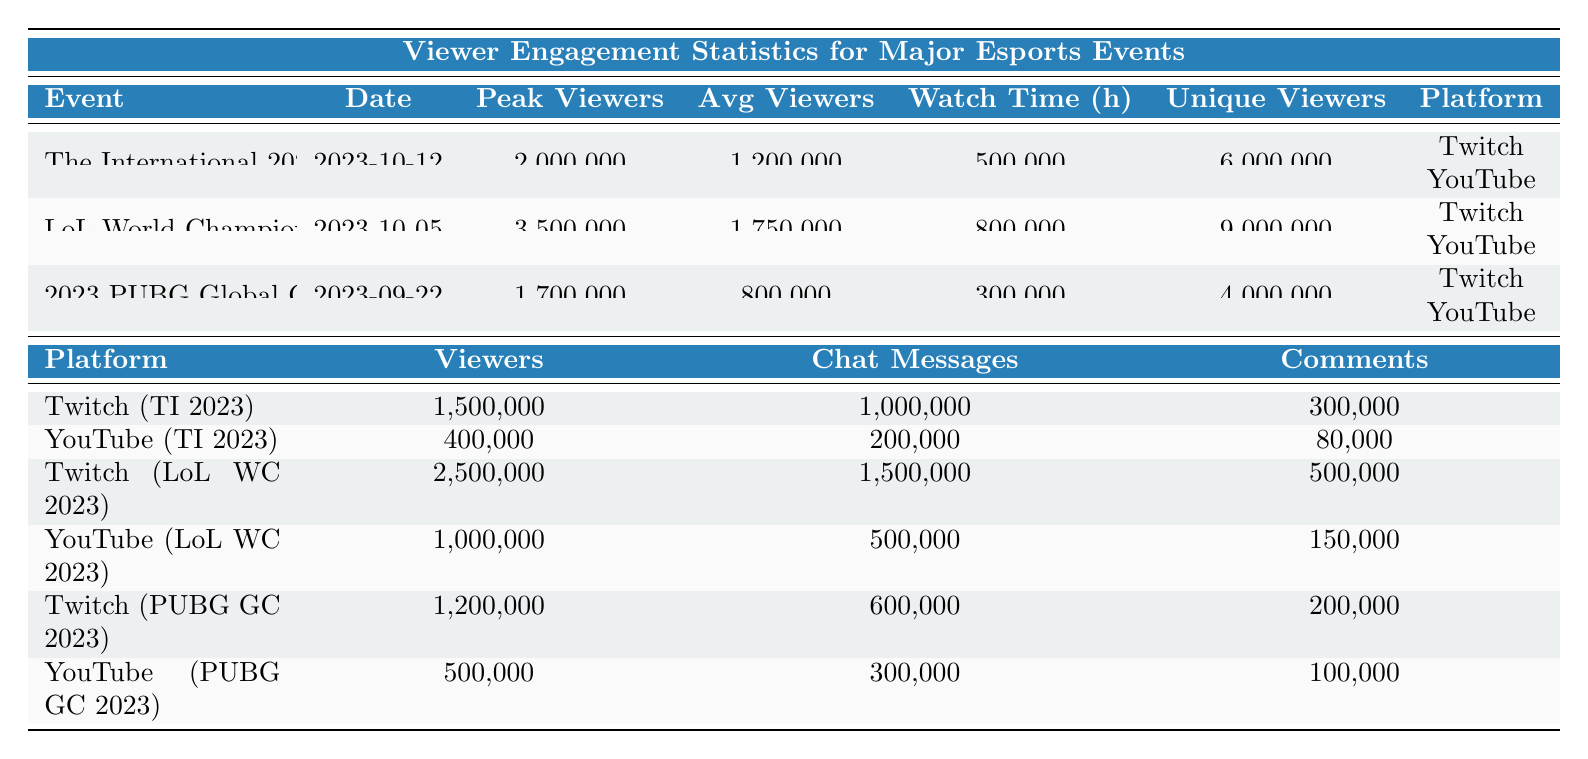What is the peak number of viewers for the League of Legends World Championship 2023? The peak viewers for each event are listed in the third column of the table. Looking at the row for the League of Legends World Championship 2023, the value in the Peak Viewers column is 3,500,000.
Answer: 3,500,000 How many unique viewers did The International 2023 attract? The unique viewers are specified in the last column for each event. For The International 2023, the unique viewers are 6,000,000, as mentioned in the table.
Answer: 6,000,000 Which platform had more viewers for the 2023 PUBG Global Championship, Twitch or YouTube? The viewers for each platform are indicated separately under the platform section of the table for PUBG Global Championship. Twitch had 1,200,000 viewers, while YouTube had 500,000 viewers. Comparing these numbers, Twitch had more viewers.
Answer: Twitch What is the total watch time in hours across all three events? To find the total watch time, sum the watch time hours from all three events: 500,000 (TI 2023) + 800,000 (LoL WC 2023) + 300,000 (PUBG GC 2023) = 1,600,000 hours.
Answer: 1,600,000 Did the League of Legends World Championship 2023 have more average viewers than The International 2023? The average viewers are provided in the table. League of Legends World Championship 2023 had 1,750,000 average viewers, while The International 2023 had 1,200,000 average viewers. Since 1,750,000 is greater than 1,200,000, the statement is true.
Answer: Yes Which event had the highest engagement on Twitch in terms of chat messages? To find the highest engagement on Twitch in terms of chat messages, look at the relevant rows for Twitch. The chat messages for each event on Twitch are: TI 2023 - 1,000,000, LoL WC 2023 - 1,500,000, and PUBG GC 2023 - 600,000. Thus, League of Legends World Championship 2023 had the highest engagement with 1,500,000 chat messages.
Answer: League of Legends World Championship 2023 What is the average number of viewers across all three esports events? To calculate the average number of viewers, first sum the average viewers for each event: 1,200,000 (TI 2023) + 1,750,000 (LoL WC 2023) + 800,000 (PUBG GC 2023) = 3,750,000. Then divide by the number of events (3): 3,750,000 / 3 = 1,250,000.
Answer: 1,250,000 Did the 2023 PUBG Global Championship have more unique viewers than The International 2023? The unique viewers are specified for each event. PUBG Global Championship had 4,000,000 unique viewers, while The International 2023 attracted 6,000,000. Since 4,000,000 is less than 6,000,000, the statement is false.
Answer: No 